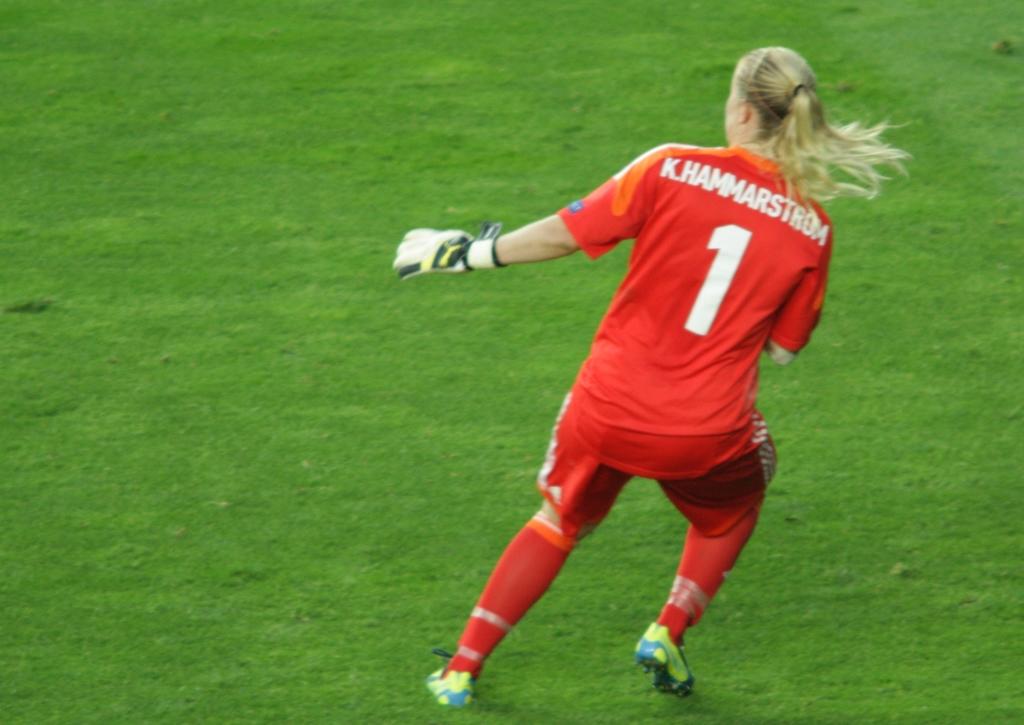What is the player's uniform number?
Your response must be concise. 1. What is the name on the back of the shirt?
Provide a short and direct response. K. hammarstrom. 